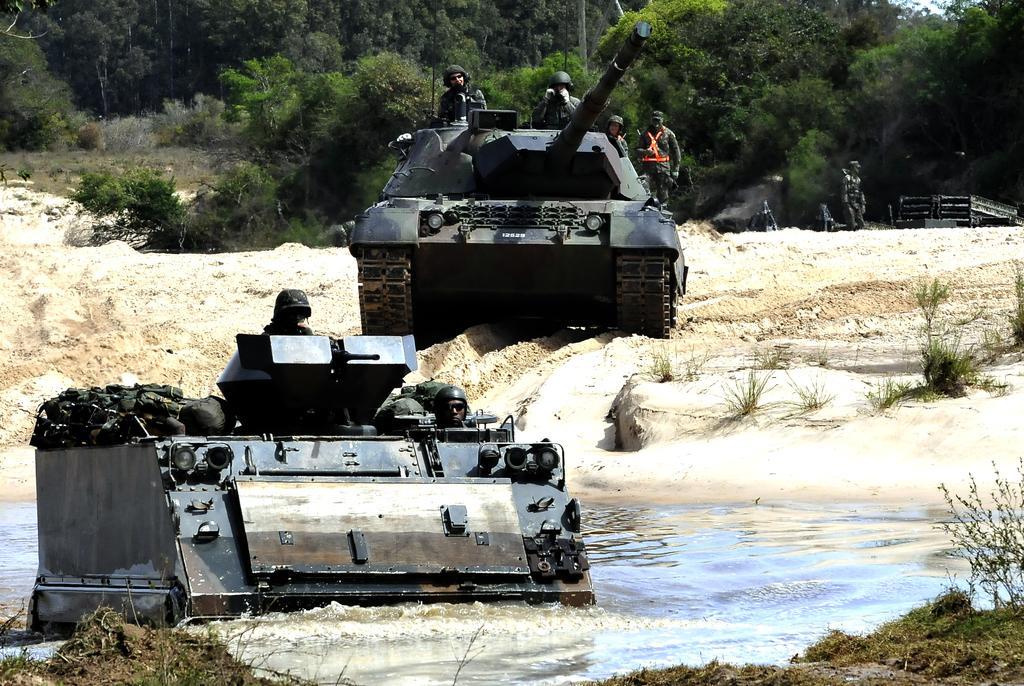How would you summarize this image in a sentence or two? In this picture there are people those who are sitting in Armored cars in the image and there is water at the bottom side of the image and there are trees in the background area of the image. 